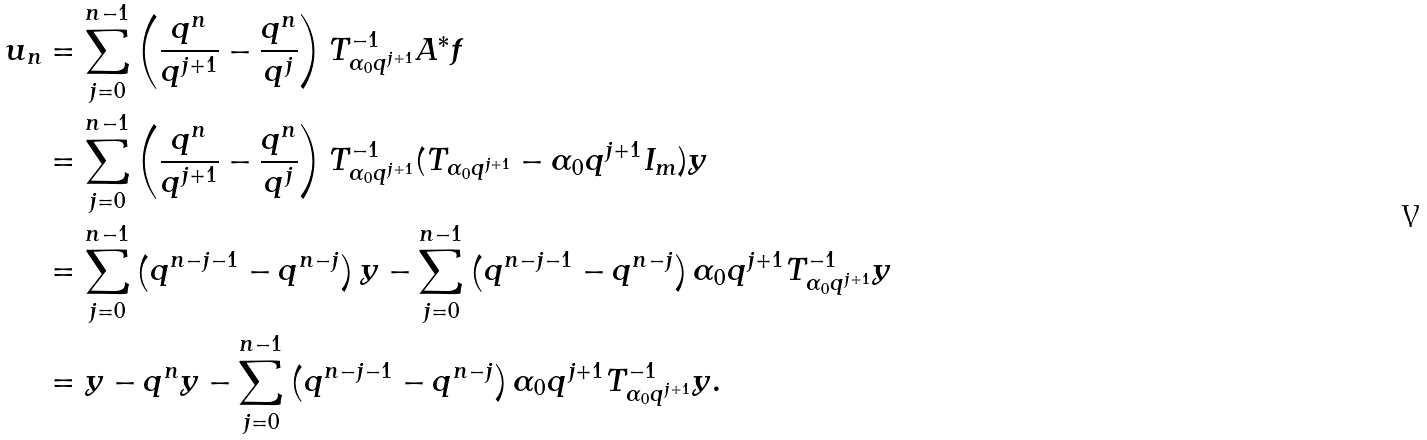Convert formula to latex. <formula><loc_0><loc_0><loc_500><loc_500>u _ { n } & = \sum _ { j = 0 } ^ { n - 1 } \left ( \frac { q ^ { n } } { q ^ { j + 1 } } - \frac { q ^ { n } } { q ^ { j } } \right ) T _ { \alpha _ { 0 } q ^ { j + 1 } } ^ { - 1 } A ^ { * } f \\ & = \sum _ { j = 0 } ^ { n - 1 } \left ( \frac { q ^ { n } } { q ^ { j + 1 } } - \frac { q ^ { n } } { q ^ { j } } \right ) T _ { \alpha _ { 0 } q ^ { j + 1 } } ^ { - 1 } ( T _ { \alpha _ { 0 } q ^ { j + 1 } } - \alpha _ { 0 } q ^ { j + 1 } I _ { m } ) y \\ & = \sum _ { j = 0 } ^ { n - 1 } \left ( q ^ { n - j - 1 } - q ^ { n - j } \right ) y - \sum _ { j = 0 } ^ { n - 1 } \left ( q ^ { n - j - 1 } - q ^ { n - j } \right ) \alpha _ { 0 } q ^ { j + 1 } T _ { \alpha _ { 0 } q ^ { j + 1 } } ^ { - 1 } y \\ & = y - q ^ { n } y - \sum _ { j = 0 } ^ { n - 1 } \left ( q ^ { n - j - 1 } - q ^ { n - j } \right ) \alpha _ { 0 } q ^ { j + 1 } T _ { \alpha _ { 0 } q ^ { j + 1 } } ^ { - 1 } y .</formula> 